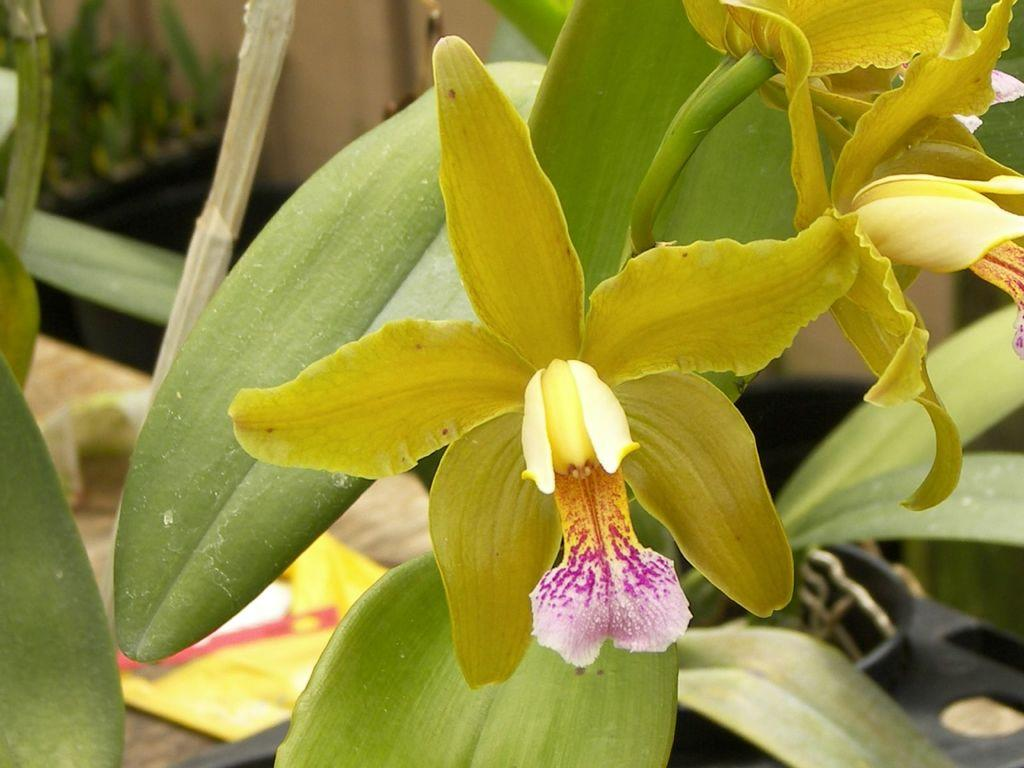What type of plants can be seen in the image? There are flowers and leaves in the image. Can you describe the appearance of the flowers? Unfortunately, the specific appearance of the flowers cannot be determined from the provided facts. What else is present in the image besides flowers and leaves? The provided facts do not mention any other objects or elements in the image. What type of chin is visible in the image? There is no chin present in the image; it features flowers and leaves. Is there a competition taking place in the image? The provided facts do not mention any competition or event in the image. 